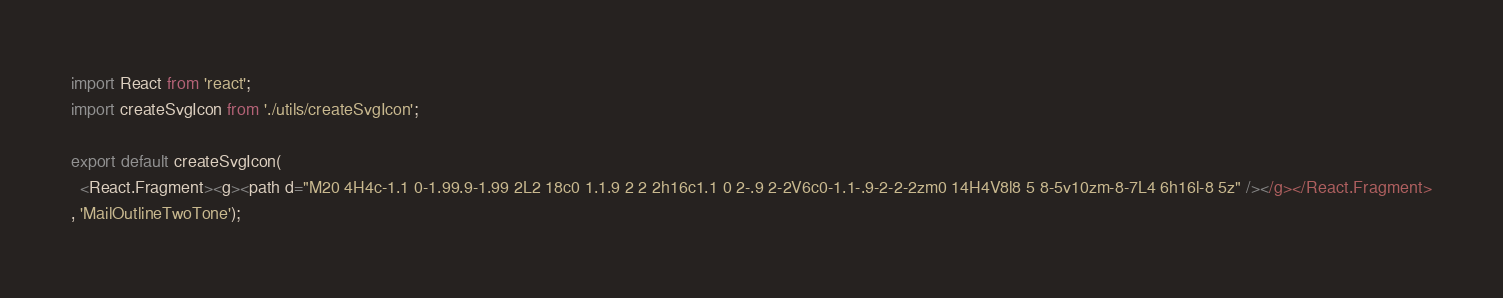<code> <loc_0><loc_0><loc_500><loc_500><_JavaScript_>import React from 'react';
import createSvgIcon from './utils/createSvgIcon';

export default createSvgIcon(
  <React.Fragment><g><path d="M20 4H4c-1.1 0-1.99.9-1.99 2L2 18c0 1.1.9 2 2 2h16c1.1 0 2-.9 2-2V6c0-1.1-.9-2-2-2zm0 14H4V8l8 5 8-5v10zm-8-7L4 6h16l-8 5z" /></g></React.Fragment>
, 'MailOutlineTwoTone');
</code> 